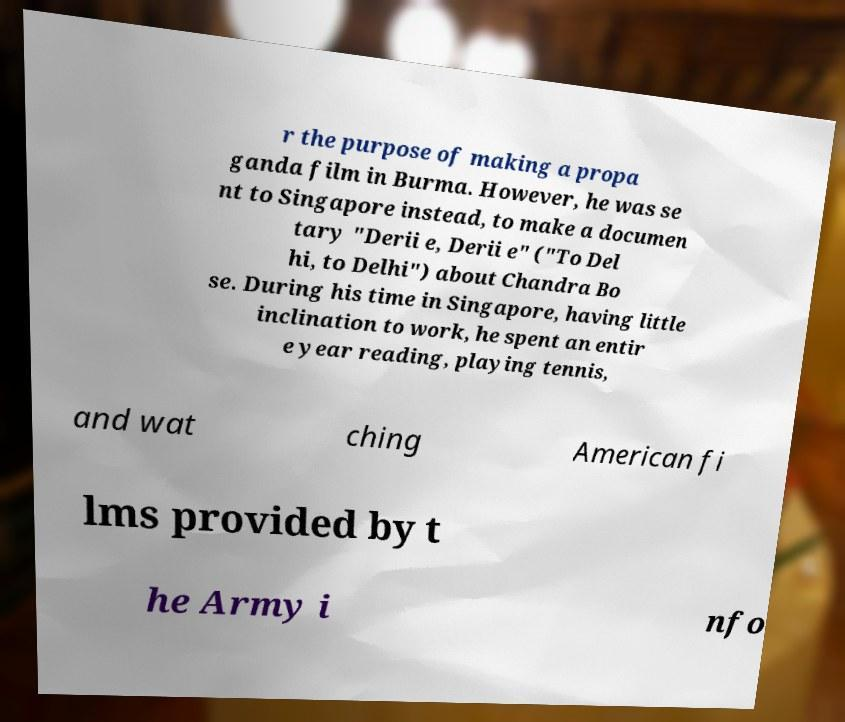Could you extract and type out the text from this image? r the purpose of making a propa ganda film in Burma. However, he was se nt to Singapore instead, to make a documen tary "Derii e, Derii e" ("To Del hi, to Delhi") about Chandra Bo se. During his time in Singapore, having little inclination to work, he spent an entir e year reading, playing tennis, and wat ching American fi lms provided by t he Army i nfo 